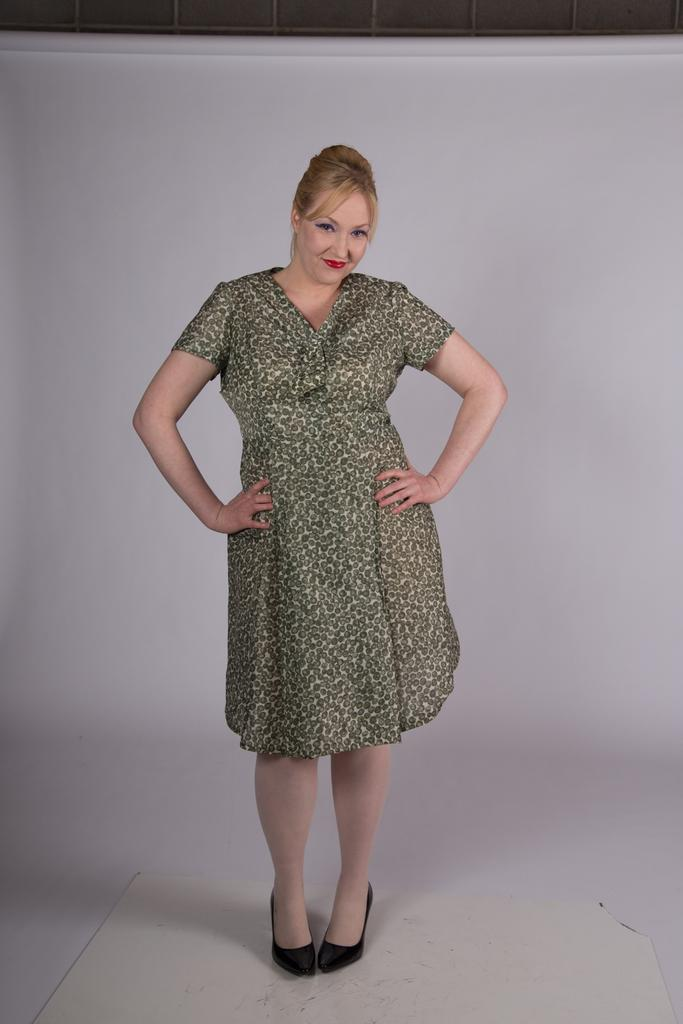What is the main subject of the image? There is a woman standing in the image. What is the woman standing on? The woman is standing on the floor. What can be seen in the background of the image? There is a wall in the background of the image. How many dogs can be seen in the image? There are no dogs present in the image. What color is the woman's eye in the image? The provided facts do not mention the color of the woman's eye, so it cannot be determined from the image. 